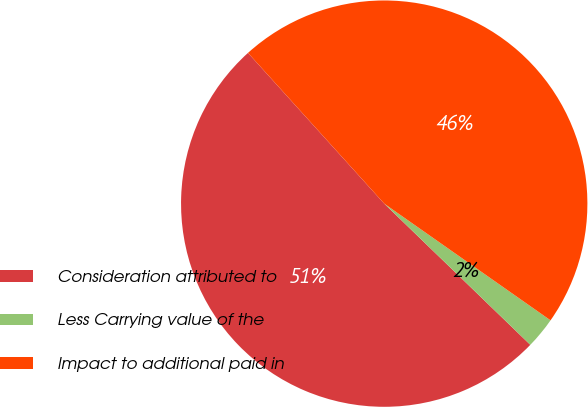Convert chart. <chart><loc_0><loc_0><loc_500><loc_500><pie_chart><fcel>Consideration attributed to<fcel>Less Carrying value of the<fcel>Impact to additional paid in<nl><fcel>51.08%<fcel>2.49%<fcel>46.44%<nl></chart> 